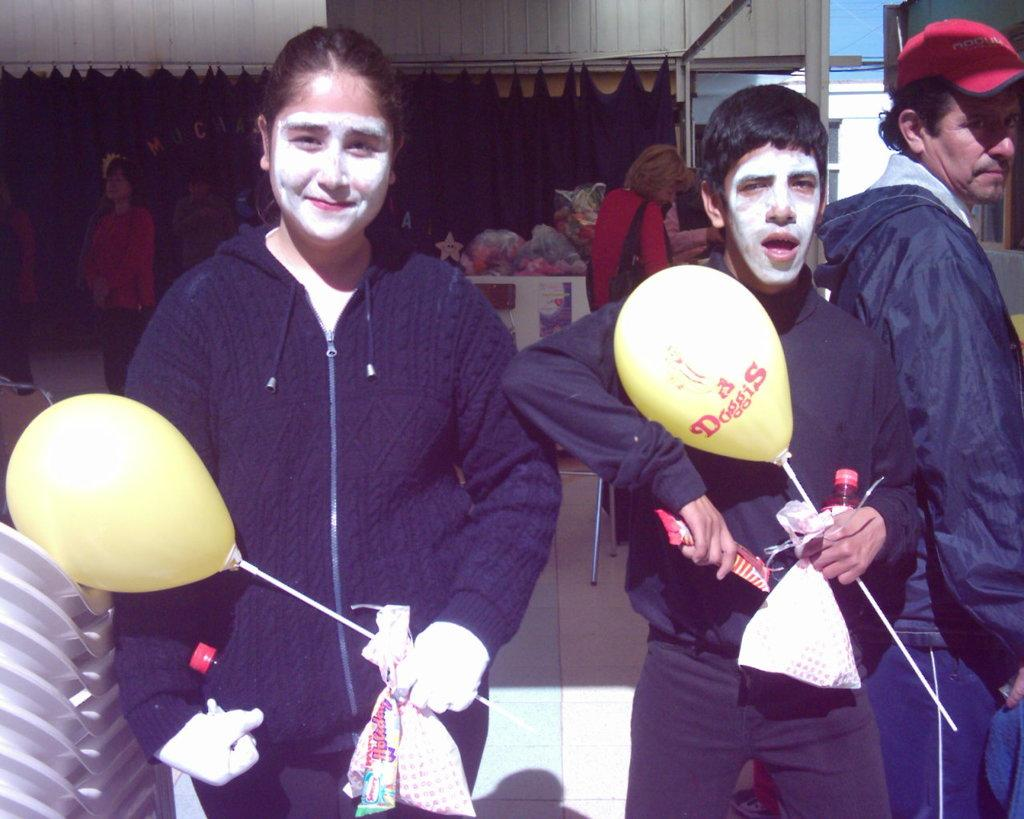Who are the people in the image? There is a girl and a boy in the image. What can be observed on their faces? Both the girl and the boy have white paint on their faces. What object are they holding in their hands? They are holding a yellow balloon in their hands. What type of impulse is causing the giants to move in the image? There are no giants present in the image, so there is no impulse causing them to move. 